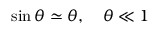<formula> <loc_0><loc_0><loc_500><loc_500>\sin \theta \simeq \theta , \quad \theta \ll 1</formula> 